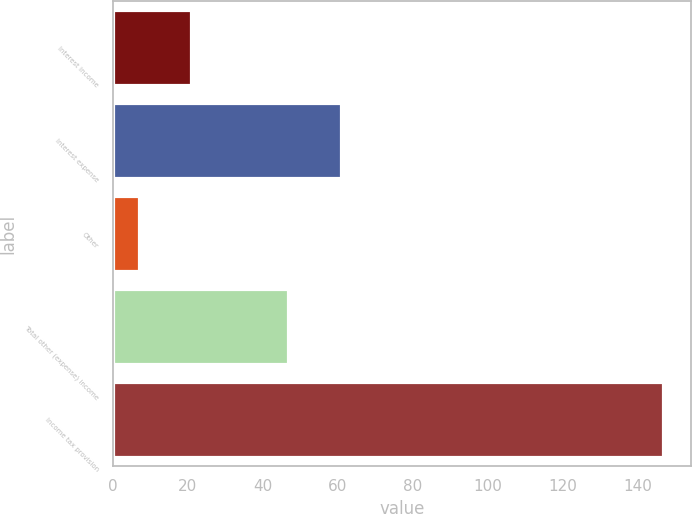Convert chart to OTSL. <chart><loc_0><loc_0><loc_500><loc_500><bar_chart><fcel>Interest income<fcel>Interest expense<fcel>Other<fcel>Total other (expense) income<fcel>Income tax provision<nl><fcel>20.97<fcel>60.77<fcel>7<fcel>46.8<fcel>146.7<nl></chart> 